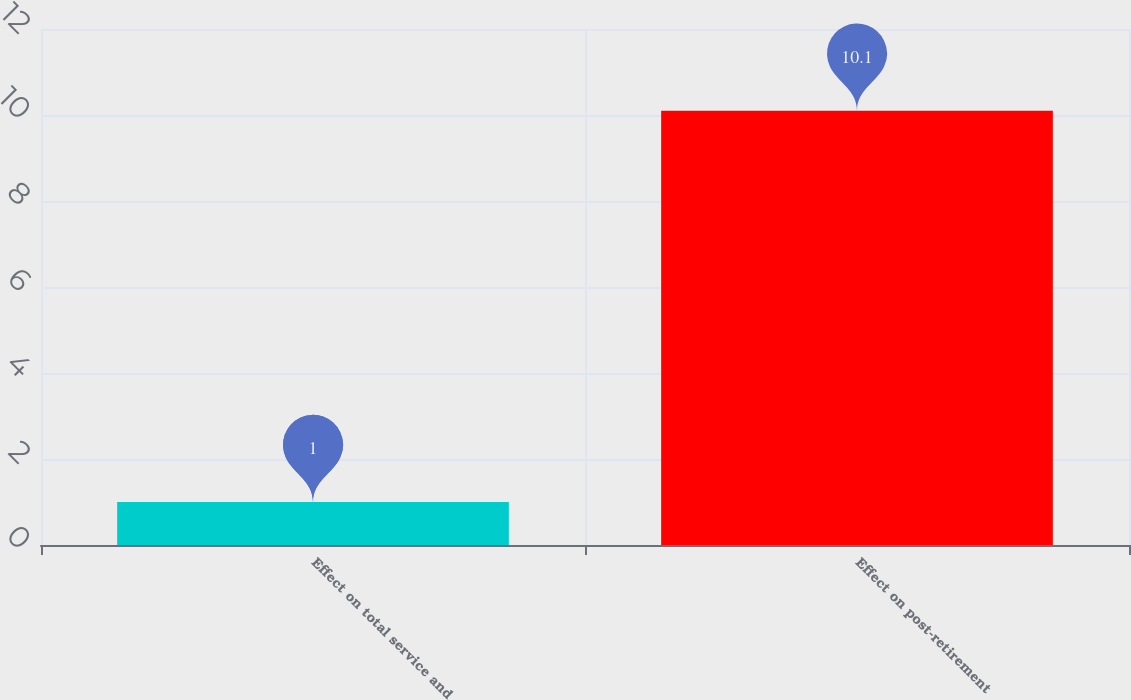Convert chart to OTSL. <chart><loc_0><loc_0><loc_500><loc_500><bar_chart><fcel>Effect on total service and<fcel>Effect on post-retirement<nl><fcel>1<fcel>10.1<nl></chart> 